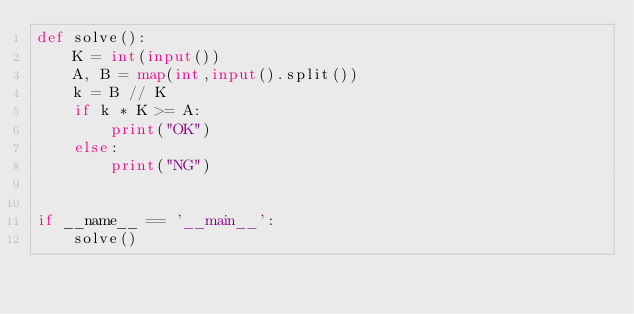Convert code to text. <code><loc_0><loc_0><loc_500><loc_500><_Python_>def solve():
    K = int(input())
    A, B = map(int,input().split())
    k = B // K
    if k * K >= A:
        print("OK")
    else:
        print("NG")
    

if __name__ == '__main__':
    solve()
</code> 